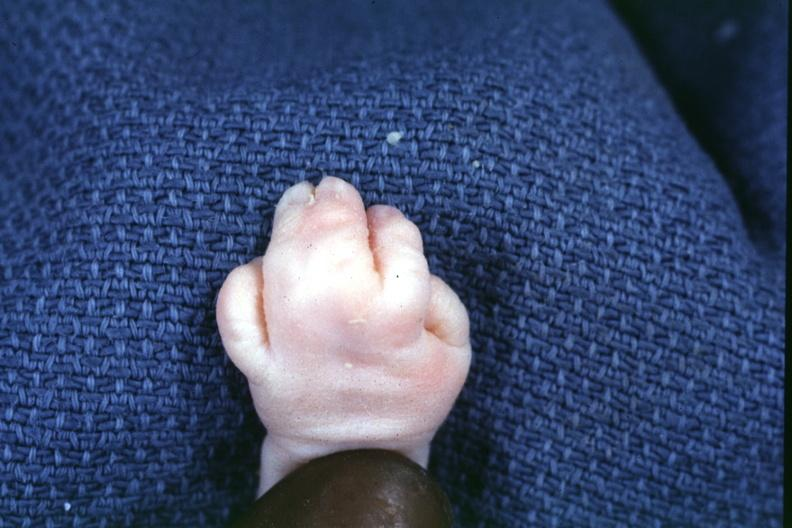s hand present?
Answer the question using a single word or phrase. Yes 